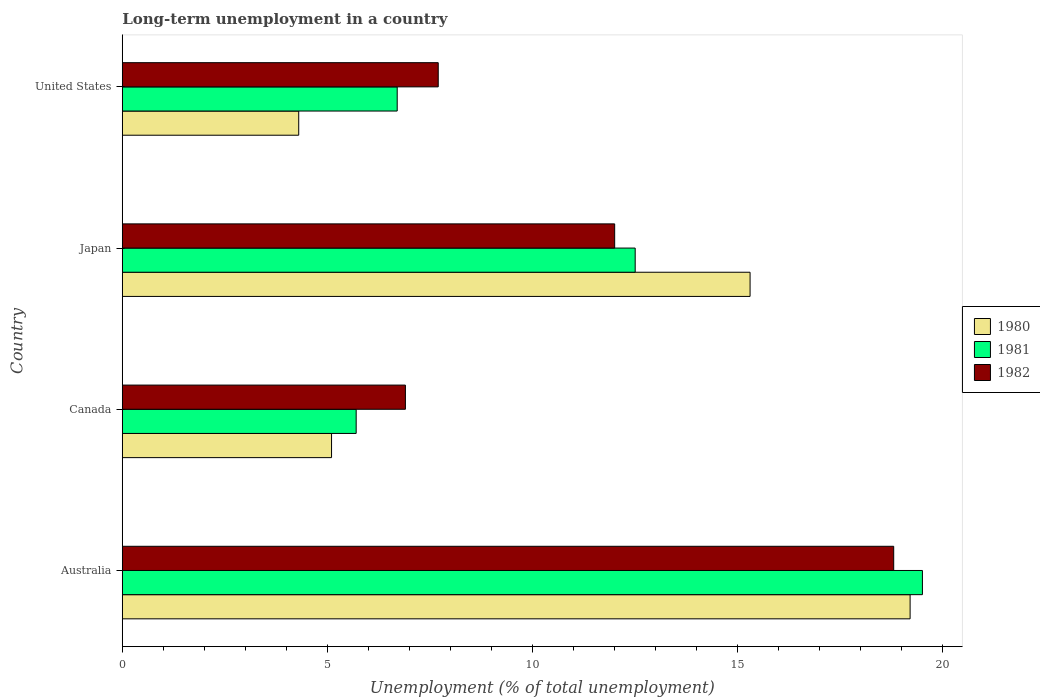How many groups of bars are there?
Give a very brief answer. 4. What is the percentage of long-term unemployed population in 1980 in Canada?
Give a very brief answer. 5.1. Across all countries, what is the maximum percentage of long-term unemployed population in 1982?
Keep it short and to the point. 18.8. Across all countries, what is the minimum percentage of long-term unemployed population in 1981?
Offer a terse response. 5.7. In which country was the percentage of long-term unemployed population in 1981 maximum?
Provide a short and direct response. Australia. What is the total percentage of long-term unemployed population in 1980 in the graph?
Ensure brevity in your answer.  43.9. What is the difference between the percentage of long-term unemployed population in 1981 in Japan and that in United States?
Make the answer very short. 5.8. What is the difference between the percentage of long-term unemployed population in 1982 in Japan and the percentage of long-term unemployed population in 1980 in Australia?
Give a very brief answer. -7.2. What is the average percentage of long-term unemployed population in 1981 per country?
Your answer should be compact. 11.1. What is the difference between the percentage of long-term unemployed population in 1981 and percentage of long-term unemployed population in 1980 in Canada?
Ensure brevity in your answer.  0.6. What is the ratio of the percentage of long-term unemployed population in 1981 in Canada to that in United States?
Keep it short and to the point. 0.85. Is the percentage of long-term unemployed population in 1981 in Japan less than that in United States?
Offer a terse response. No. Is the difference between the percentage of long-term unemployed population in 1981 in Japan and United States greater than the difference between the percentage of long-term unemployed population in 1980 in Japan and United States?
Ensure brevity in your answer.  No. What is the difference between the highest and the second highest percentage of long-term unemployed population in 1980?
Provide a short and direct response. 3.9. What is the difference between the highest and the lowest percentage of long-term unemployed population in 1982?
Give a very brief answer. 11.9. In how many countries, is the percentage of long-term unemployed population in 1980 greater than the average percentage of long-term unemployed population in 1980 taken over all countries?
Give a very brief answer. 2. What does the 2nd bar from the top in Canada represents?
Your answer should be compact. 1981. What does the 1st bar from the bottom in Canada represents?
Provide a succinct answer. 1980. Is it the case that in every country, the sum of the percentage of long-term unemployed population in 1982 and percentage of long-term unemployed population in 1981 is greater than the percentage of long-term unemployed population in 1980?
Provide a succinct answer. Yes. Are all the bars in the graph horizontal?
Your answer should be compact. Yes. How many countries are there in the graph?
Your response must be concise. 4. How many legend labels are there?
Your answer should be compact. 3. What is the title of the graph?
Offer a very short reply. Long-term unemployment in a country. What is the label or title of the X-axis?
Your answer should be very brief. Unemployment (% of total unemployment). What is the label or title of the Y-axis?
Your answer should be very brief. Country. What is the Unemployment (% of total unemployment) of 1980 in Australia?
Provide a succinct answer. 19.2. What is the Unemployment (% of total unemployment) in 1981 in Australia?
Give a very brief answer. 19.5. What is the Unemployment (% of total unemployment) in 1982 in Australia?
Ensure brevity in your answer.  18.8. What is the Unemployment (% of total unemployment) in 1980 in Canada?
Make the answer very short. 5.1. What is the Unemployment (% of total unemployment) of 1981 in Canada?
Offer a very short reply. 5.7. What is the Unemployment (% of total unemployment) of 1982 in Canada?
Give a very brief answer. 6.9. What is the Unemployment (% of total unemployment) of 1980 in Japan?
Give a very brief answer. 15.3. What is the Unemployment (% of total unemployment) of 1982 in Japan?
Give a very brief answer. 12. What is the Unemployment (% of total unemployment) in 1980 in United States?
Provide a succinct answer. 4.3. What is the Unemployment (% of total unemployment) of 1981 in United States?
Make the answer very short. 6.7. What is the Unemployment (% of total unemployment) of 1982 in United States?
Your answer should be very brief. 7.7. Across all countries, what is the maximum Unemployment (% of total unemployment) of 1980?
Offer a terse response. 19.2. Across all countries, what is the maximum Unemployment (% of total unemployment) of 1981?
Give a very brief answer. 19.5. Across all countries, what is the maximum Unemployment (% of total unemployment) in 1982?
Keep it short and to the point. 18.8. Across all countries, what is the minimum Unemployment (% of total unemployment) in 1980?
Give a very brief answer. 4.3. Across all countries, what is the minimum Unemployment (% of total unemployment) of 1981?
Provide a succinct answer. 5.7. Across all countries, what is the minimum Unemployment (% of total unemployment) in 1982?
Your response must be concise. 6.9. What is the total Unemployment (% of total unemployment) of 1980 in the graph?
Your answer should be compact. 43.9. What is the total Unemployment (% of total unemployment) of 1981 in the graph?
Provide a succinct answer. 44.4. What is the total Unemployment (% of total unemployment) in 1982 in the graph?
Ensure brevity in your answer.  45.4. What is the difference between the Unemployment (% of total unemployment) of 1980 in Australia and that in Canada?
Your answer should be compact. 14.1. What is the difference between the Unemployment (% of total unemployment) of 1981 in Australia and that in Canada?
Your answer should be very brief. 13.8. What is the difference between the Unemployment (% of total unemployment) in 1981 in Australia and that in Japan?
Your answer should be compact. 7. What is the difference between the Unemployment (% of total unemployment) of 1981 in Australia and that in United States?
Keep it short and to the point. 12.8. What is the difference between the Unemployment (% of total unemployment) of 1982 in Australia and that in United States?
Make the answer very short. 11.1. What is the difference between the Unemployment (% of total unemployment) in 1980 in Canada and that in Japan?
Provide a succinct answer. -10.2. What is the difference between the Unemployment (% of total unemployment) in 1981 in Canada and that in Japan?
Give a very brief answer. -6.8. What is the difference between the Unemployment (% of total unemployment) in 1982 in Canada and that in Japan?
Give a very brief answer. -5.1. What is the difference between the Unemployment (% of total unemployment) in 1980 in Canada and that in United States?
Your answer should be compact. 0.8. What is the difference between the Unemployment (% of total unemployment) of 1981 in Canada and that in United States?
Your answer should be compact. -1. What is the difference between the Unemployment (% of total unemployment) in 1982 in Canada and that in United States?
Ensure brevity in your answer.  -0.8. What is the difference between the Unemployment (% of total unemployment) of 1982 in Japan and that in United States?
Your answer should be compact. 4.3. What is the difference between the Unemployment (% of total unemployment) of 1980 in Australia and the Unemployment (% of total unemployment) of 1981 in Canada?
Make the answer very short. 13.5. What is the difference between the Unemployment (% of total unemployment) of 1980 in Australia and the Unemployment (% of total unemployment) of 1982 in Canada?
Provide a short and direct response. 12.3. What is the difference between the Unemployment (% of total unemployment) in 1981 in Australia and the Unemployment (% of total unemployment) in 1982 in Canada?
Your answer should be very brief. 12.6. What is the difference between the Unemployment (% of total unemployment) of 1980 in Australia and the Unemployment (% of total unemployment) of 1982 in United States?
Offer a terse response. 11.5. What is the difference between the Unemployment (% of total unemployment) in 1980 in Canada and the Unemployment (% of total unemployment) in 1981 in Japan?
Make the answer very short. -7.4. What is the difference between the Unemployment (% of total unemployment) of 1980 in Canada and the Unemployment (% of total unemployment) of 1982 in Japan?
Ensure brevity in your answer.  -6.9. What is the difference between the Unemployment (% of total unemployment) of 1980 in Canada and the Unemployment (% of total unemployment) of 1981 in United States?
Offer a terse response. -1.6. What is the difference between the Unemployment (% of total unemployment) in 1981 in Canada and the Unemployment (% of total unemployment) in 1982 in United States?
Provide a short and direct response. -2. What is the difference between the Unemployment (% of total unemployment) in 1980 in Japan and the Unemployment (% of total unemployment) in 1981 in United States?
Ensure brevity in your answer.  8.6. What is the average Unemployment (% of total unemployment) of 1980 per country?
Keep it short and to the point. 10.97. What is the average Unemployment (% of total unemployment) of 1981 per country?
Ensure brevity in your answer.  11.1. What is the average Unemployment (% of total unemployment) of 1982 per country?
Give a very brief answer. 11.35. What is the difference between the Unemployment (% of total unemployment) in 1981 and Unemployment (% of total unemployment) in 1982 in Canada?
Provide a short and direct response. -1.2. What is the difference between the Unemployment (% of total unemployment) in 1981 and Unemployment (% of total unemployment) in 1982 in Japan?
Provide a short and direct response. 0.5. What is the difference between the Unemployment (% of total unemployment) in 1981 and Unemployment (% of total unemployment) in 1982 in United States?
Keep it short and to the point. -1. What is the ratio of the Unemployment (% of total unemployment) in 1980 in Australia to that in Canada?
Your response must be concise. 3.76. What is the ratio of the Unemployment (% of total unemployment) of 1981 in Australia to that in Canada?
Your answer should be very brief. 3.42. What is the ratio of the Unemployment (% of total unemployment) of 1982 in Australia to that in Canada?
Your answer should be compact. 2.72. What is the ratio of the Unemployment (% of total unemployment) in 1980 in Australia to that in Japan?
Ensure brevity in your answer.  1.25. What is the ratio of the Unemployment (% of total unemployment) in 1981 in Australia to that in Japan?
Provide a short and direct response. 1.56. What is the ratio of the Unemployment (% of total unemployment) in 1982 in Australia to that in Japan?
Keep it short and to the point. 1.57. What is the ratio of the Unemployment (% of total unemployment) of 1980 in Australia to that in United States?
Your answer should be compact. 4.47. What is the ratio of the Unemployment (% of total unemployment) in 1981 in Australia to that in United States?
Provide a succinct answer. 2.91. What is the ratio of the Unemployment (% of total unemployment) of 1982 in Australia to that in United States?
Ensure brevity in your answer.  2.44. What is the ratio of the Unemployment (% of total unemployment) of 1980 in Canada to that in Japan?
Ensure brevity in your answer.  0.33. What is the ratio of the Unemployment (% of total unemployment) of 1981 in Canada to that in Japan?
Ensure brevity in your answer.  0.46. What is the ratio of the Unemployment (% of total unemployment) of 1982 in Canada to that in Japan?
Your answer should be compact. 0.57. What is the ratio of the Unemployment (% of total unemployment) in 1980 in Canada to that in United States?
Provide a short and direct response. 1.19. What is the ratio of the Unemployment (% of total unemployment) in 1981 in Canada to that in United States?
Ensure brevity in your answer.  0.85. What is the ratio of the Unemployment (% of total unemployment) in 1982 in Canada to that in United States?
Offer a terse response. 0.9. What is the ratio of the Unemployment (% of total unemployment) in 1980 in Japan to that in United States?
Make the answer very short. 3.56. What is the ratio of the Unemployment (% of total unemployment) of 1981 in Japan to that in United States?
Make the answer very short. 1.87. What is the ratio of the Unemployment (% of total unemployment) of 1982 in Japan to that in United States?
Ensure brevity in your answer.  1.56. What is the difference between the highest and the second highest Unemployment (% of total unemployment) of 1980?
Ensure brevity in your answer.  3.9. What is the difference between the highest and the second highest Unemployment (% of total unemployment) of 1982?
Offer a very short reply. 6.8. 